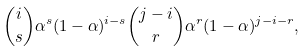<formula> <loc_0><loc_0><loc_500><loc_500>\binom { i } { s } \alpha ^ { s } ( 1 - \alpha ) ^ { i - s } \binom { j - i } r \alpha ^ { r } ( 1 - \alpha ) ^ { j - i - r } ,</formula> 